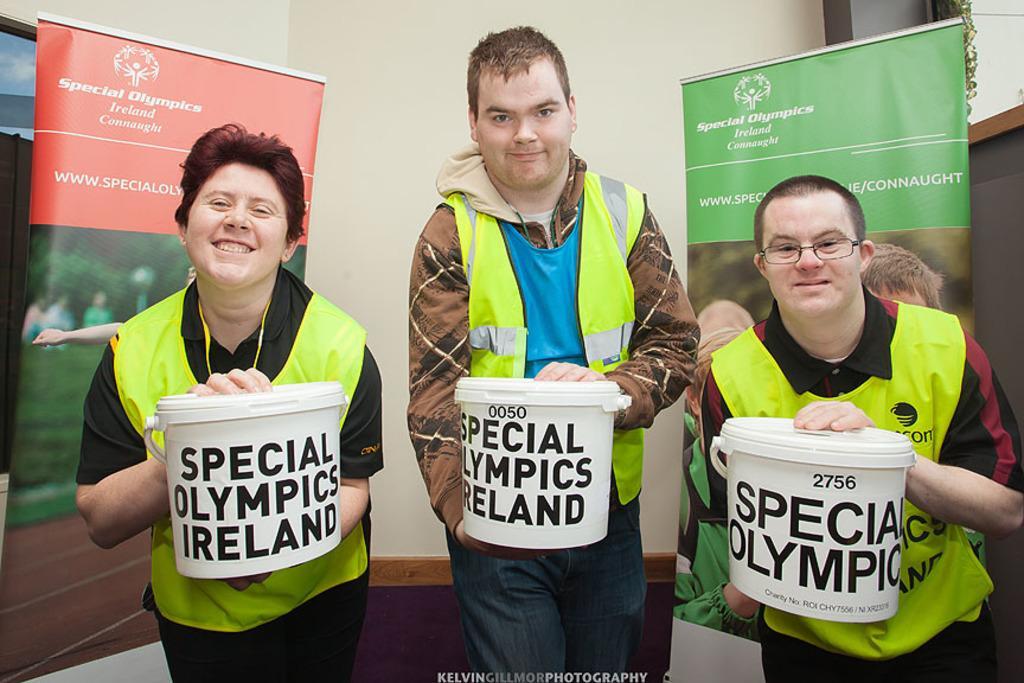Could you give a brief overview of what you see in this image? In this image we can see three persons holding buckets and in the background there are banners and a wall. 